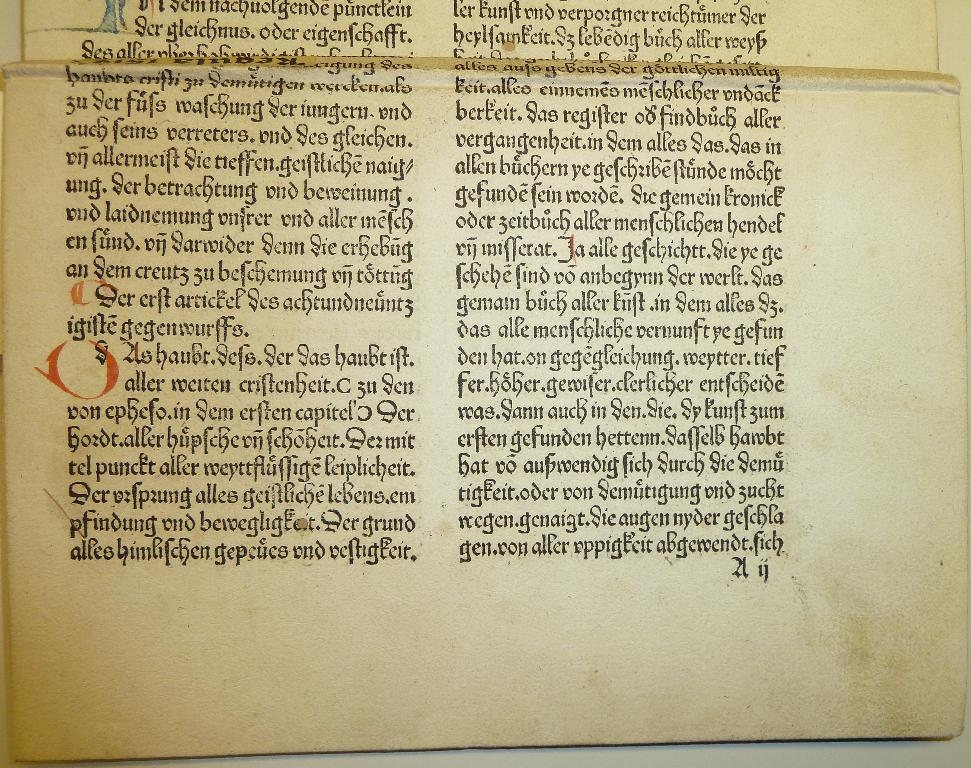What is the last word on the page?
Provide a short and direct response. Fich. What is the red letter?
Ensure brevity in your answer.  O. 